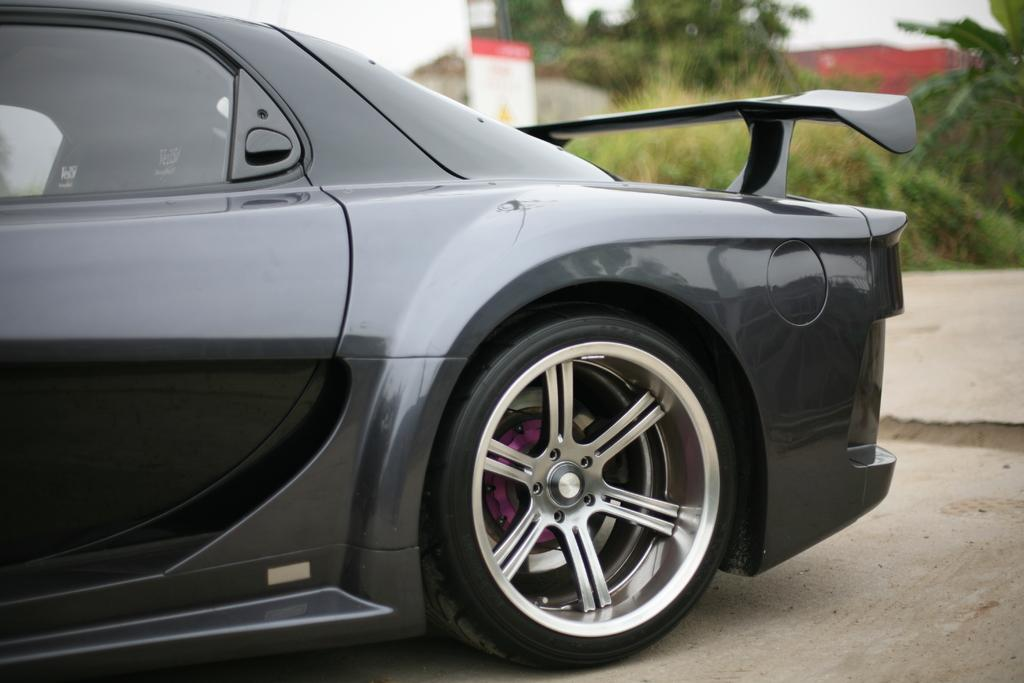What is the main subject of the image? There is a car on the ground in the image. Can you describe the background of the image? The background of the image is blurred, but there is a hoarding, a building, plants, trees, and the sky visible. What type of structure can be seen in the background? There is a building in the background. What natural elements are present in the background? Plants, trees, and the sky are visible in the background. Can you tell me how many jellyfish are swimming in the car's engine in the image? There are no jellyfish present in the image, and therefore none can be found in the car's engine. What type of watch is the maid wearing in the image? There is no maid or watch present in the image. 